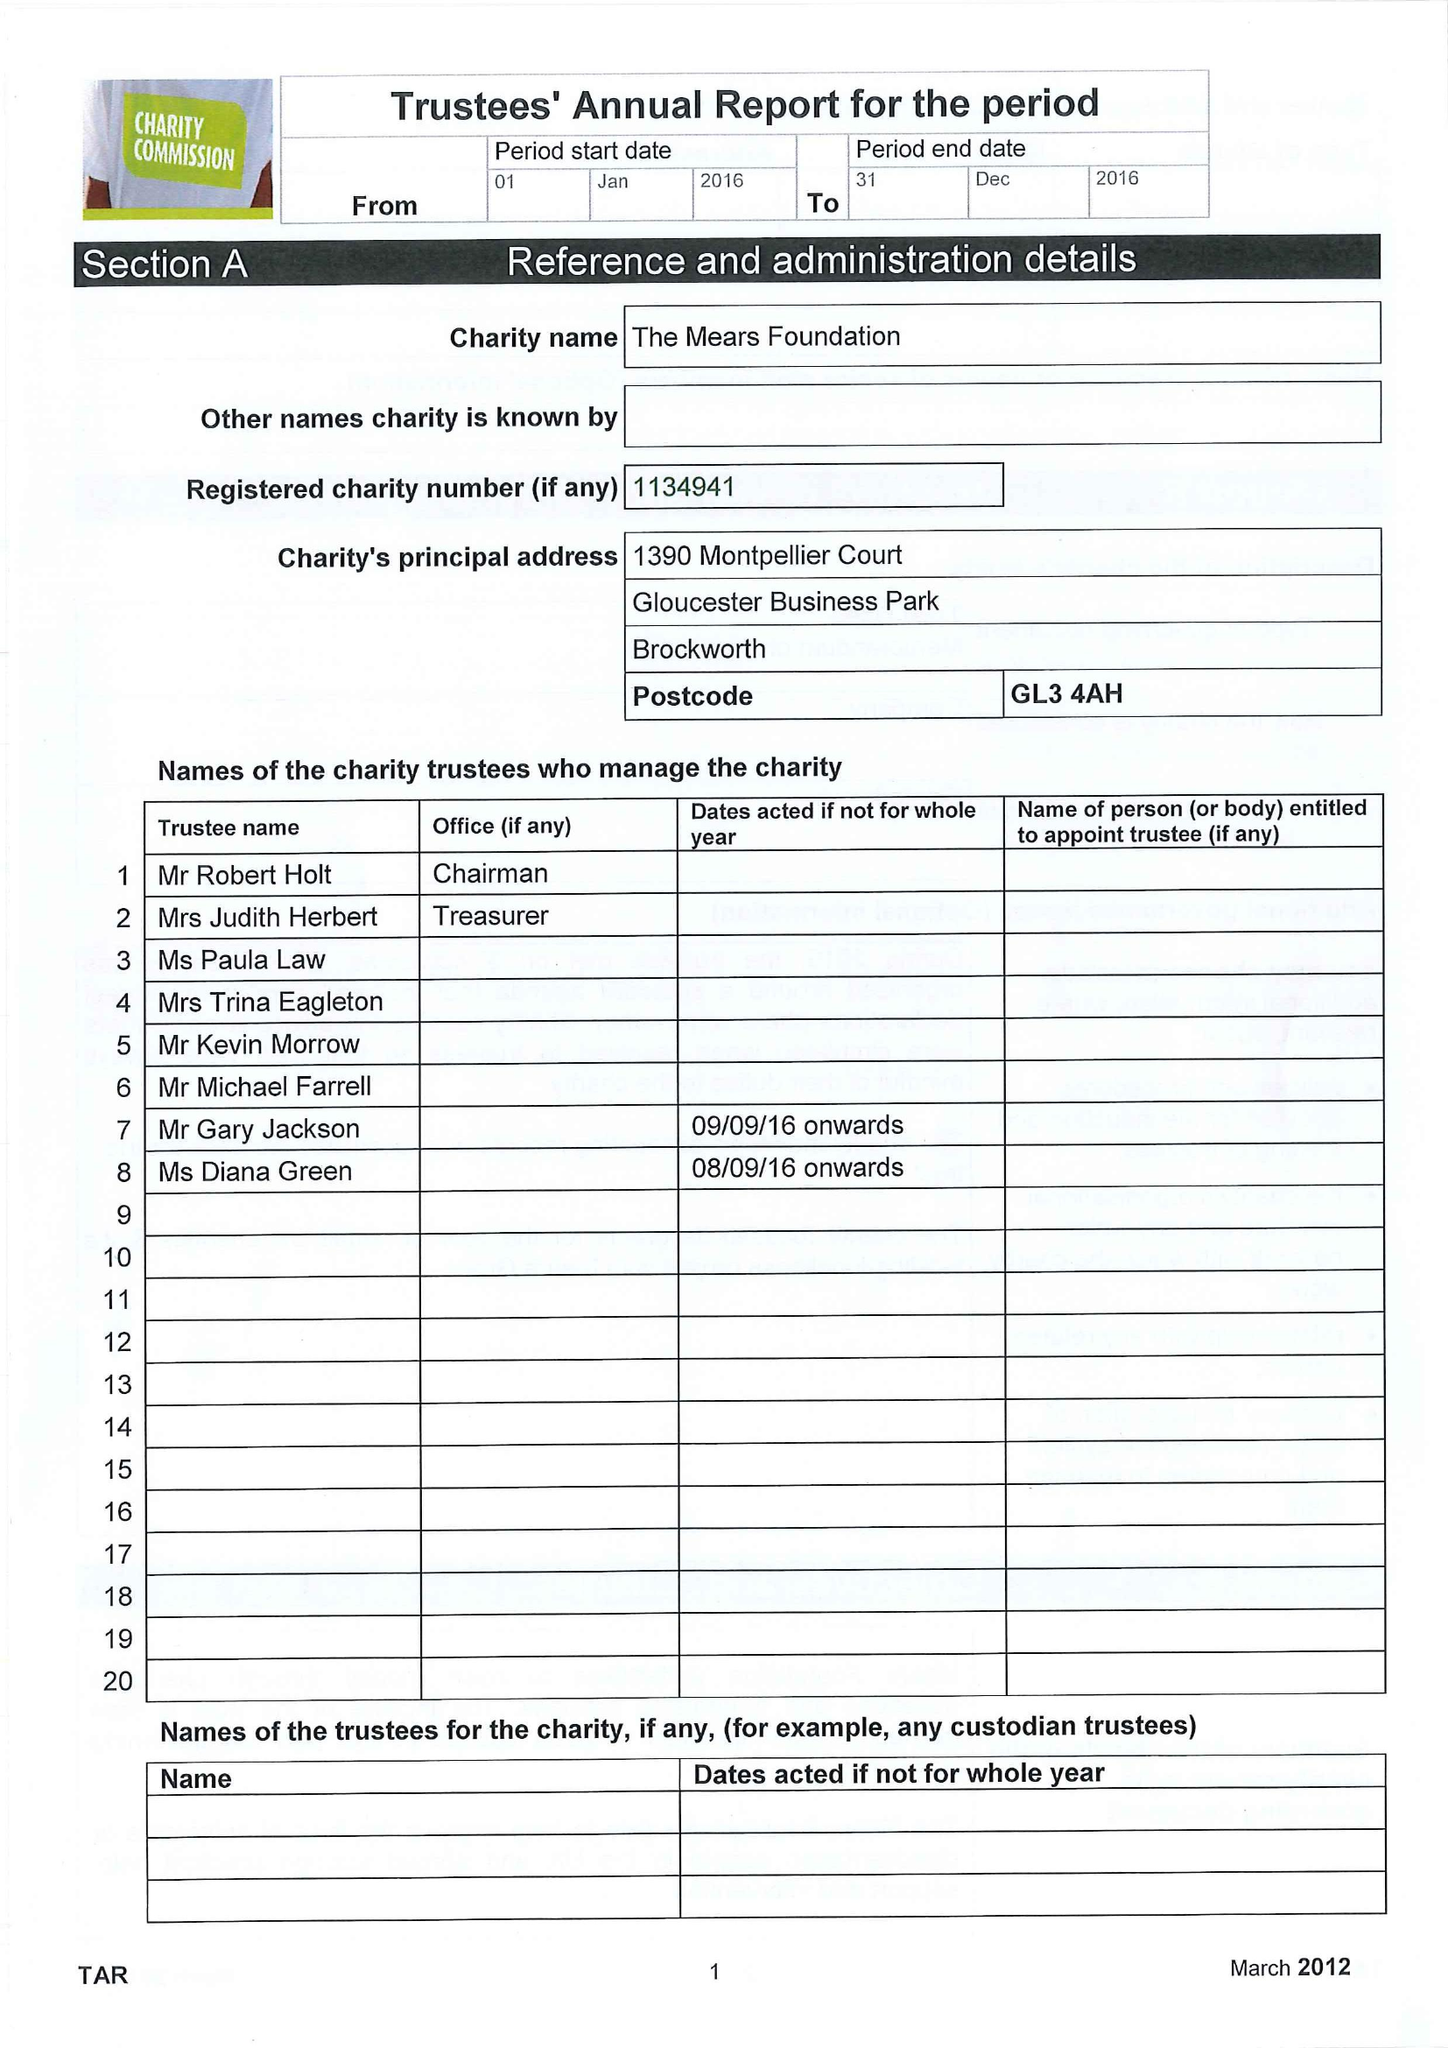What is the value for the address__post_town?
Answer the question using a single word or phrase. GLOUCESTER 